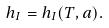<formula> <loc_0><loc_0><loc_500><loc_500>h _ { I } = h _ { I } ( T , a ) .</formula> 